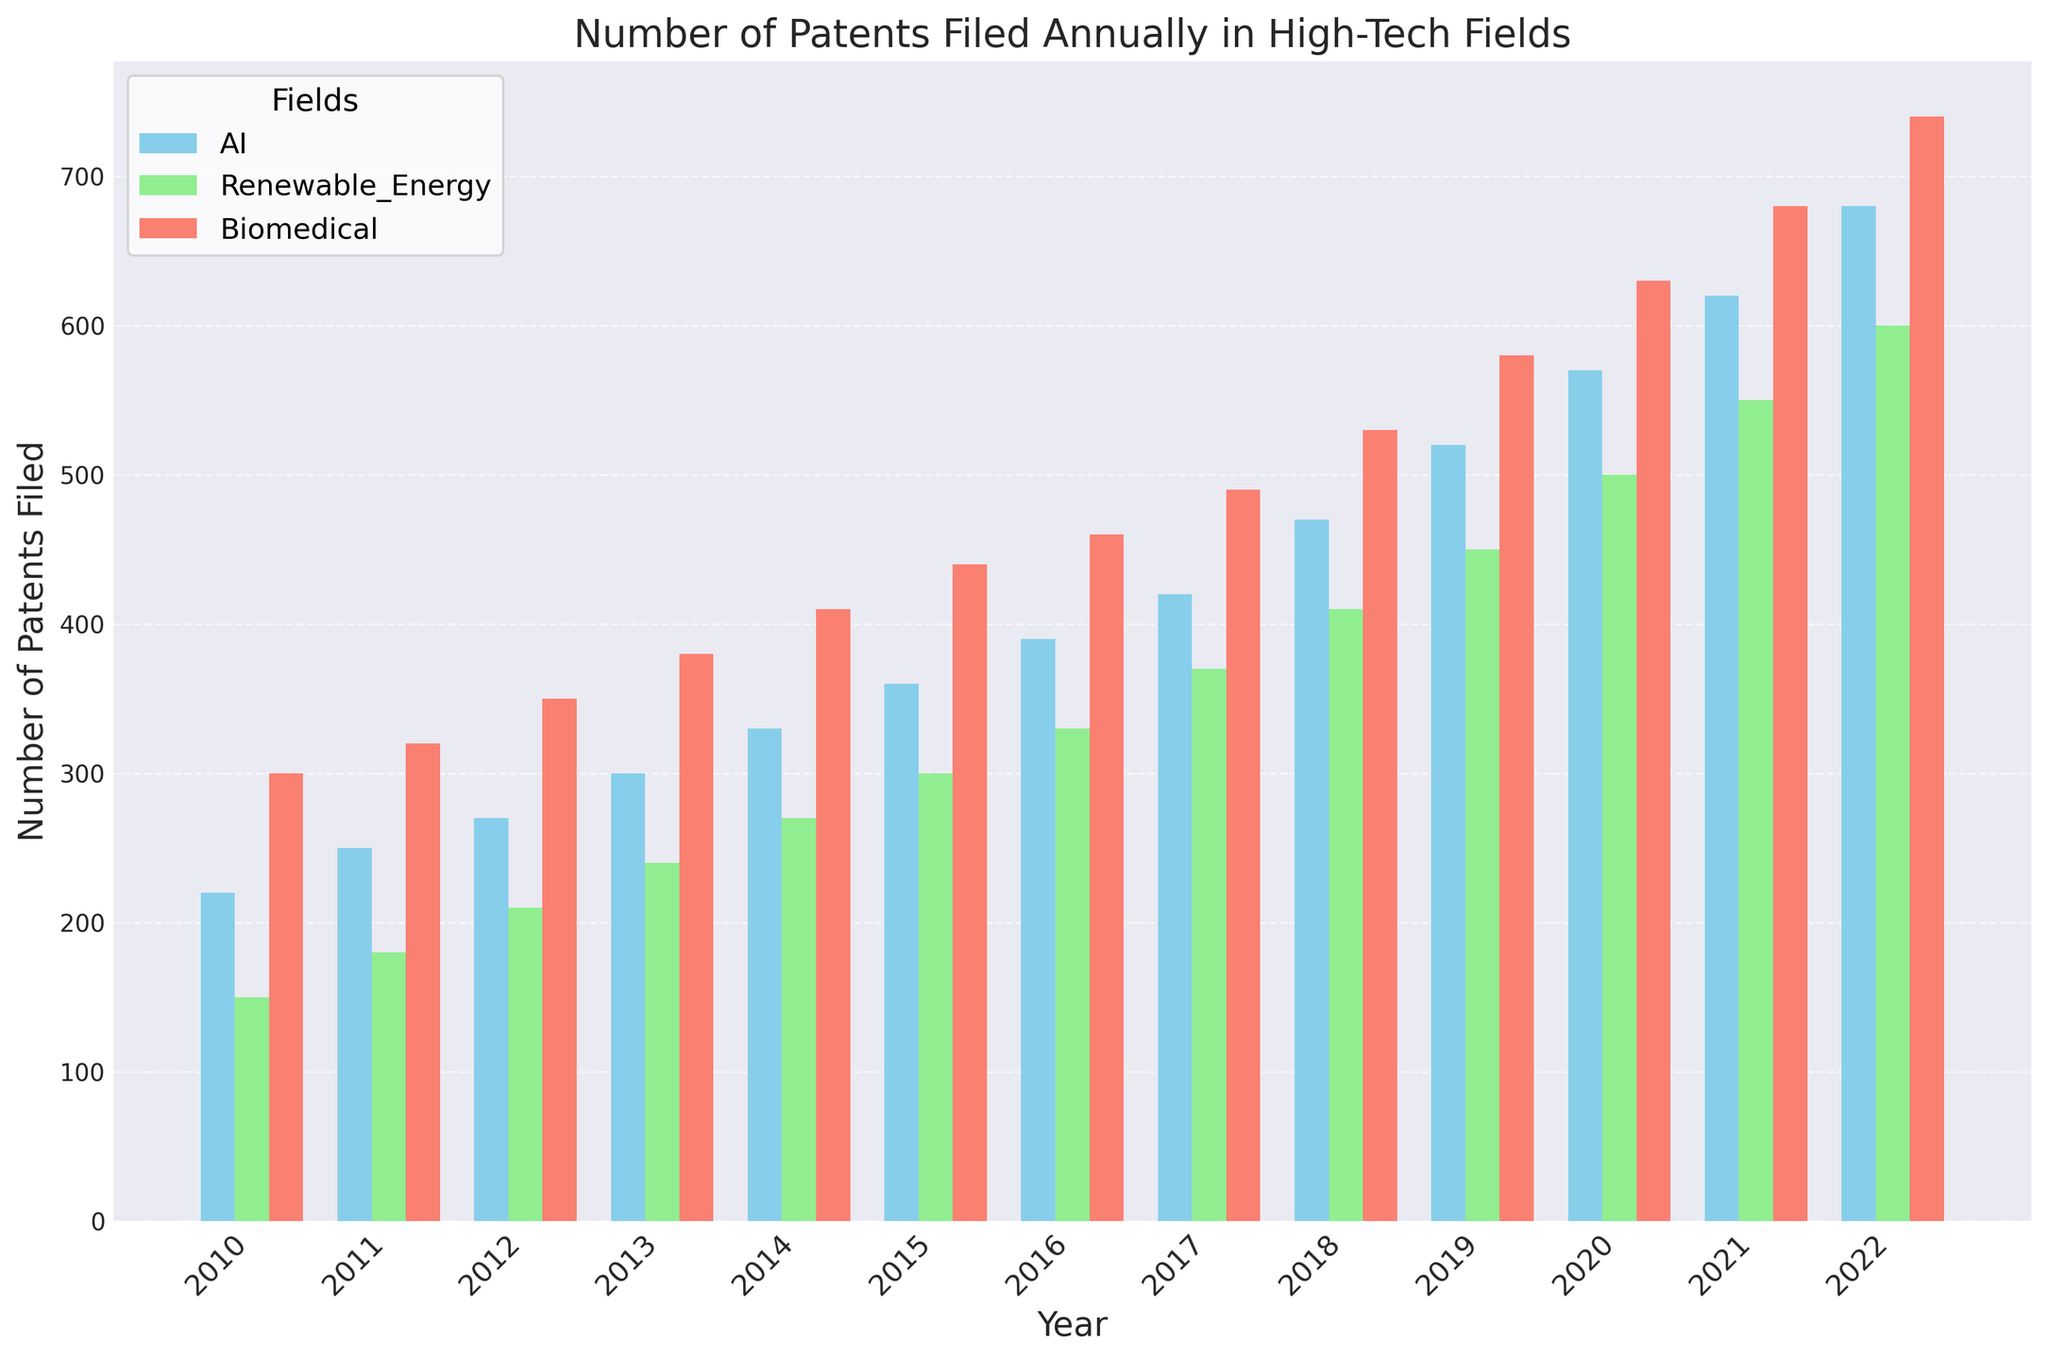How many patents were filed for AI and Biomedical in the year 2012 combined? In 2012, the number of patents filed for AI was 270, and for Biomedical, it was 350. Adding them together gives 270 + 350 = 620.
Answer: 620 In which year did the number of Renewable Energy patents first exceed 400? By examining the bars for Renewable Energy, the first year the number exceeds 400 is 2018.
Answer: 2018 Which field saw the highest growth in the number of patents filed between 2010 and 2022? AI patents grew from 220 in 2010 to 680 in 2022, Renewable Energy grew from 150 to 600, and Biomedical grew from 300 to 740. The growth for AI is 680 - 220 = 460, for Renewable Energy is 600 - 150 = 450, and for Biomedical is 740 - 300 = 440. AI saw the highest growth.
Answer: AI What is the average number of patents filed for all fields combined in 2020? In 2020, the numbers are: AI - 570, Renewable Energy - 500, Biomedical - 630. Average = (570 + 500 + 630) / 3 = 1700 / 3 ≈ 567.
Answer: 567 Which field had the smallest number of patents filed in 2017, and what was the count? The numbers for 2017 are: AI - 420, Renewable Energy - 370, Biomedical - 490. Renewable Energy had the smallest count.
Answer: Renewable Energy, 370 Which year saw the smallest number of patents filed for Renewable Energy, and how many were filed? The smallest number of patents filed for Renewable Energy was in 2010, with 150 patents.
Answer: 2010, 150 By how much did the number of Biomedical patents increase between 2015 and 2022? The number of Biomedical patents in 2015 was 440, and in 2022, it was 740. The increase is 740 - 440 = 300.
Answer: 300 What's the total number of patents filed for AI in the period from 2010 to 2016? The numbers are: 220 (2010), 250 (2011), 270 (2012), 300 (2013), 330 (2014), 360 (2015), 390 (2016). Total = 220 + 250 + 270 + 300 + 330 + 360 + 390 = 2120.
Answer: 2120 